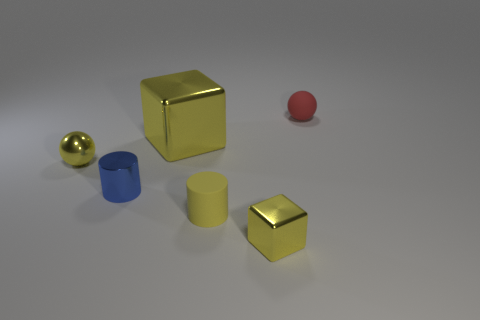Add 3 small red rubber balls. How many objects exist? 9 Subtract all balls. How many objects are left? 4 Subtract 0 cyan balls. How many objects are left? 6 Subtract all small brown spheres. Subtract all yellow cylinders. How many objects are left? 5 Add 4 red things. How many red things are left? 5 Add 1 large cyan objects. How many large cyan objects exist? 1 